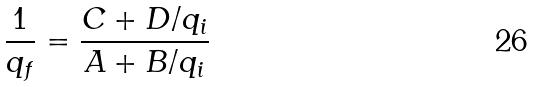Convert formula to latex. <formula><loc_0><loc_0><loc_500><loc_500>\frac { 1 } { q _ { f } } = \frac { C + D / q _ { i } } { A + B / q _ { i } }</formula> 